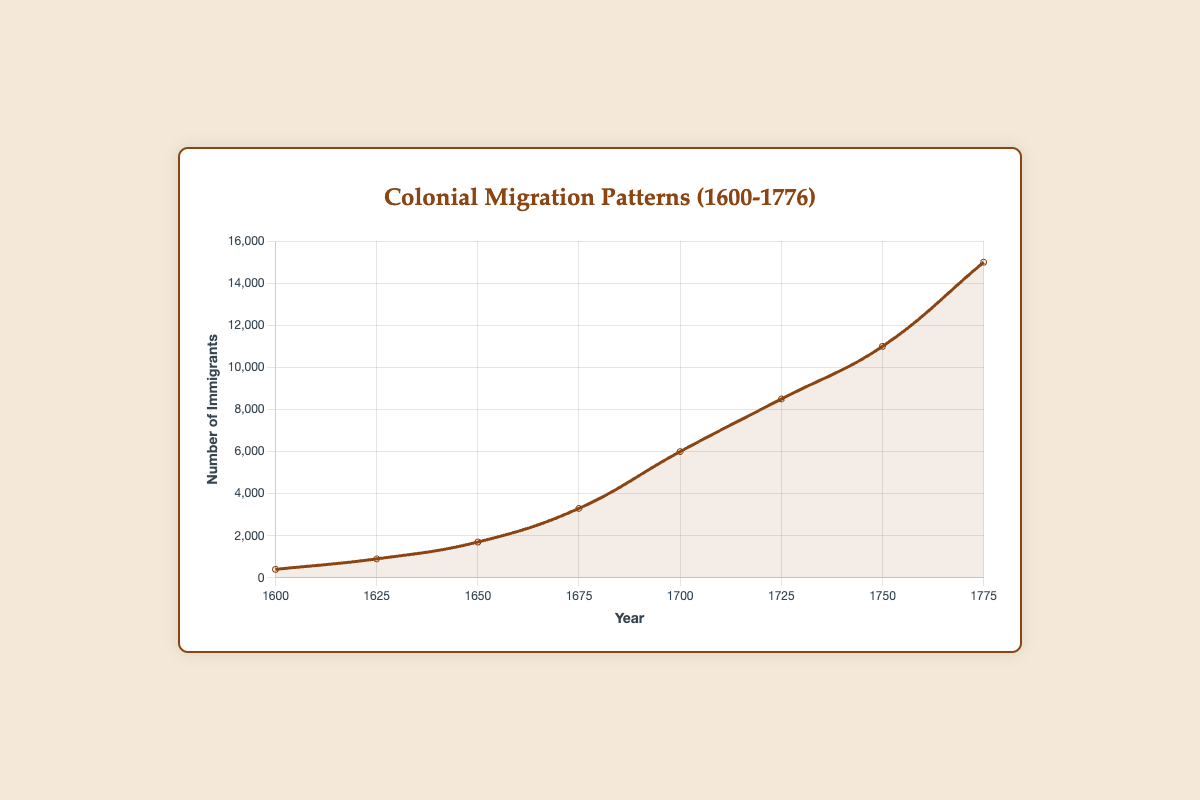What was the highest number of immigrants in a single year? The highest point on the curve represents the maximum number of immigrants. The curve peaks at 1775 with 15000 immigrants
Answer: 15000 In which year did we see the highest increase in the number of immigrants compared to the previous data point? By calculating the difference in the number of immigrants between consecutive years: 1625-1600 (900-400=500), 1650-1625 (1700-900=800), 1675-1650 (3300-1700=1600), 1700-1675 (6000-3300=2700), 1725-1700 (8500-6000=2500), 1750-1725 (11000-8500=2500), 1775-1750 (15000-11000=4000). The increase is highest from 1750 to 1775 with 4000
Answer: 1775 What is the total number of immigrants from 1600 to 1775? Adding up all the recorded numbers of immigrants: 400 + 900 + 1700 + 3300 + 6000 + 8500 + 11000 + 15000 = 47400
Answer: 47400 Was the number of immigrants in 1700 greater than in 1625? Comparing the values for the years 1700 (6000 immigrants) and 1625 (900 immigrants): 6000 > 900
Answer: Yes Between which two consecutive time points was the growth rate in the number of immigrants the slowest? Calculating the difference in the number of immigrants between consecutive years and comparing: 1625-1600 (500), 1650-1625 (800), 1675-1650 (1600), 1700-1675 (2700), 1725-1700 (2500), 1750-1725 (2500), 1775-1750 (4000). The smallest difference is from 1600 to 1625
Answer: 1600 to 1625 What regions were added as origins of immigrants between 1600 and 1625? According to the tooltip information, immigrants in 1600 came from England and Scotland. In 1625, the regions of origin were England and Ireland. Comparing these two sets, Ireland was added by 1625
Answer: Ireland What is the median number of immigrants recorded between 1600 and 1775? Listing out the numbers of immigrants in ascending order: 400, 900, 1700, 3300, 6000, 8500, 11000, 15000. Since there are 8 data points (even number), the median is the average of the 4th and 5th values: (3300 + 6000) / 2 = 4650
Answer: 4650 How many regions of origin were listed for immigrants in 1775? The tooltip for the year 1775 shows the regions: England, Scotland, Wales, Germany, Ireland, Netherlands, France, Africa. Counting these regions gives 8
Answer: 8 Was the number of immigrants in 1750 less than or equal to twice the number in 1700? The number of immigrants in 1750 is 11000, and in 1700 it is 6000. Multiply the 1700 number by 2: 6000 * 2 = 12000. Since 11000 ≤ 12000
Answer: Yes Which year had a number of immigrants closest to 5000? Looking at the figures, the number of immigrants in 1700 is 6000, which is the closest to 5000
Answer: 1700 